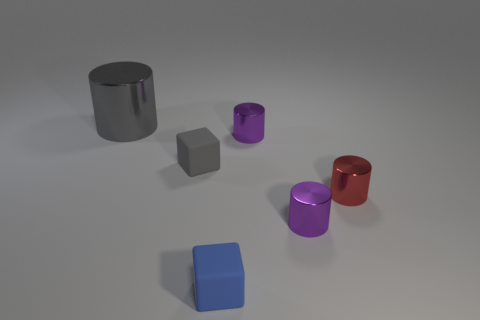Subtract all large gray cylinders. How many cylinders are left? 3 Subtract all red cylinders. How many cylinders are left? 3 Subtract all cylinders. How many objects are left? 2 Add 2 large cylinders. How many large cylinders are left? 3 Add 5 blue cubes. How many blue cubes exist? 6 Add 2 small rubber objects. How many objects exist? 8 Subtract 0 green spheres. How many objects are left? 6 Subtract 2 cylinders. How many cylinders are left? 2 Subtract all yellow cubes. Subtract all brown cylinders. How many cubes are left? 2 Subtract all green cylinders. How many green blocks are left? 0 